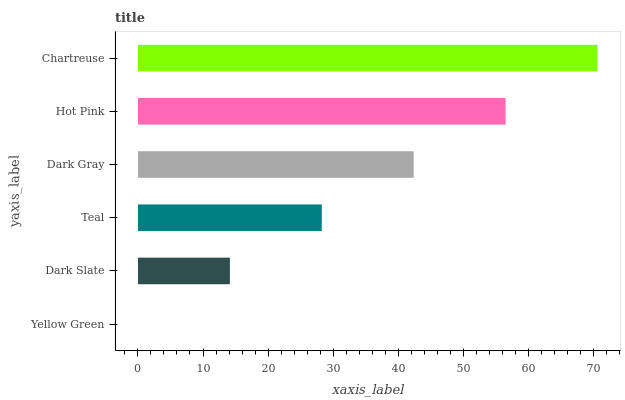Is Yellow Green the minimum?
Answer yes or no. Yes. Is Chartreuse the maximum?
Answer yes or no. Yes. Is Dark Slate the minimum?
Answer yes or no. No. Is Dark Slate the maximum?
Answer yes or no. No. Is Dark Slate greater than Yellow Green?
Answer yes or no. Yes. Is Yellow Green less than Dark Slate?
Answer yes or no. Yes. Is Yellow Green greater than Dark Slate?
Answer yes or no. No. Is Dark Slate less than Yellow Green?
Answer yes or no. No. Is Dark Gray the high median?
Answer yes or no. Yes. Is Teal the low median?
Answer yes or no. Yes. Is Dark Slate the high median?
Answer yes or no. No. Is Hot Pink the low median?
Answer yes or no. No. 